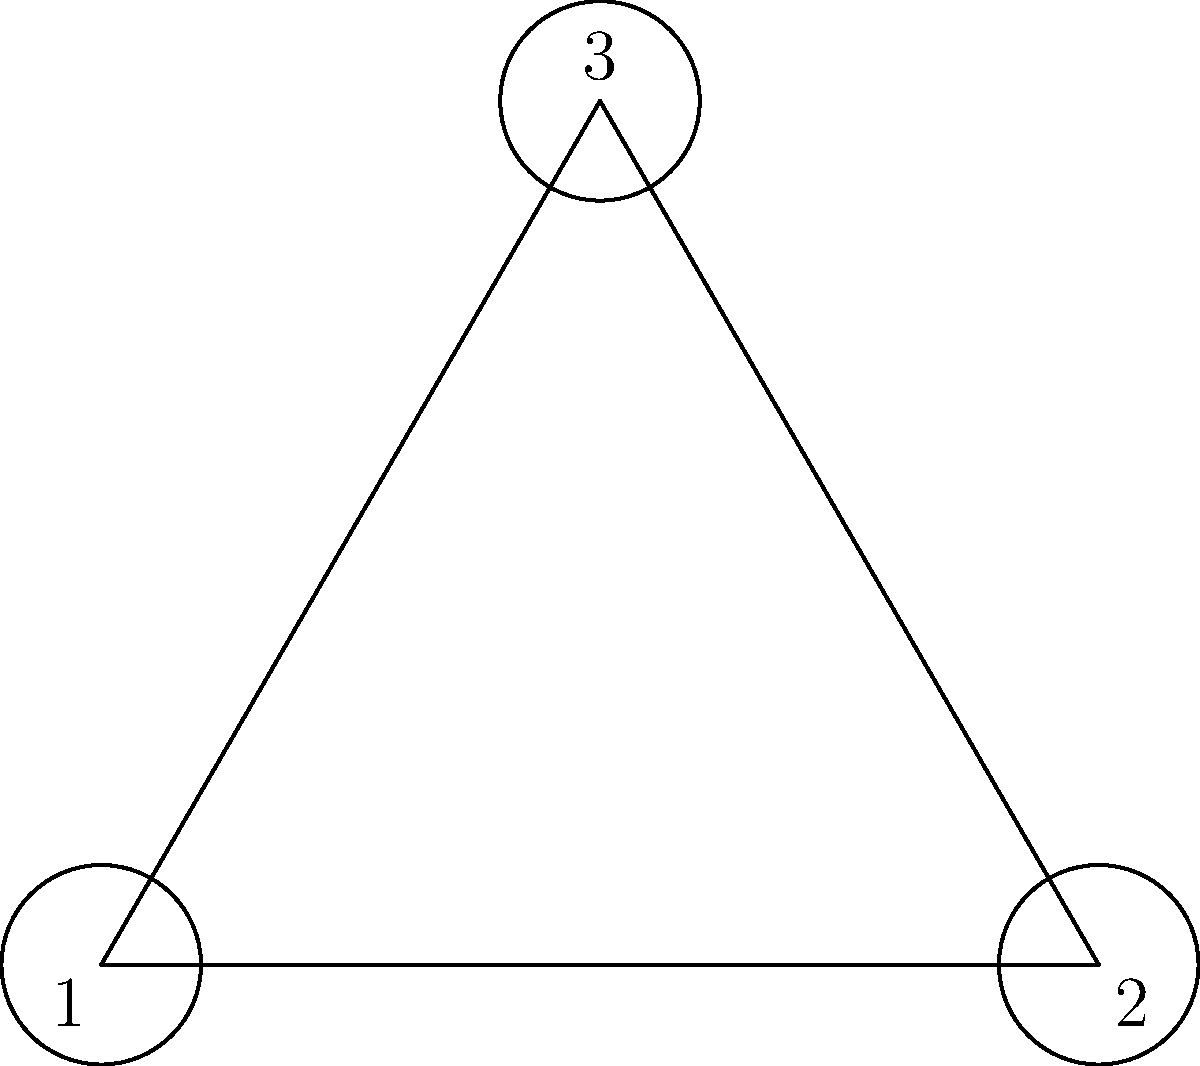In the diagram above, a cricket field is represented by an equilateral triangle. Three circular fielding positions are marked at the vertices. If the field is rotated 120° clockwise around its center, how many fielding positions will coincide with their original locations? To solve this problem, we need to understand rotational symmetry and how it applies to an equilateral triangle:

1. An equilateral triangle has 3-fold rotational symmetry, meaning it looks the same after a rotation of 120° or 240° around its center.

2. The fielding positions are located at the vertices of the triangle.

3. When we rotate the triangle 120° clockwise:
   - Vertex 1 moves to the position of vertex 3
   - Vertex 2 moves to the position of vertex 1
   - Vertex 3 moves to the position of vertex 2

4. This means that after a 120° rotation, none of the fielding positions coincide with their original locations.

5. Each vertex (and thus each fielding position) returns to its original location only after a full 360° rotation.

Therefore, when the field is rotated 120° clockwise around its center, 0 fielding positions will coincide with their original locations.
Answer: 0 